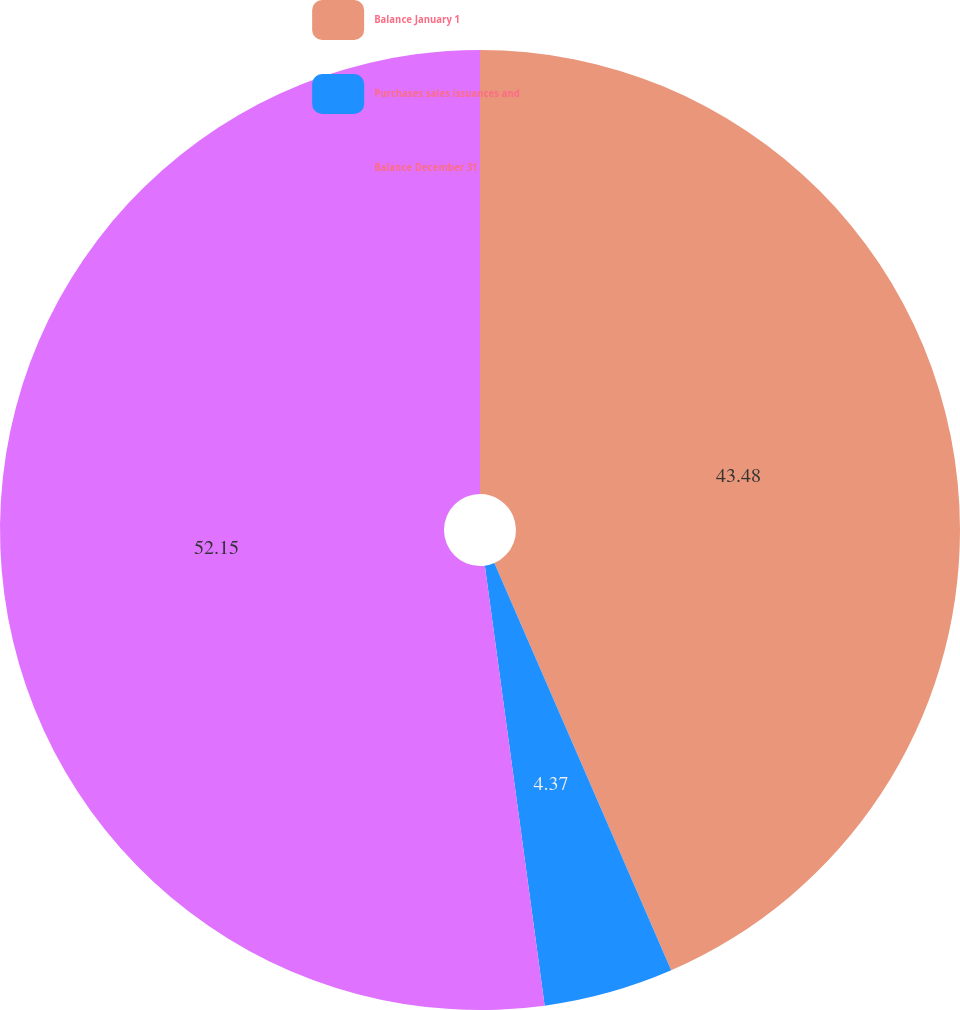<chart> <loc_0><loc_0><loc_500><loc_500><pie_chart><fcel>Balance January 1<fcel>Purchases sales issuances and<fcel>Balance December 31<nl><fcel>43.48%<fcel>4.37%<fcel>52.15%<nl></chart> 